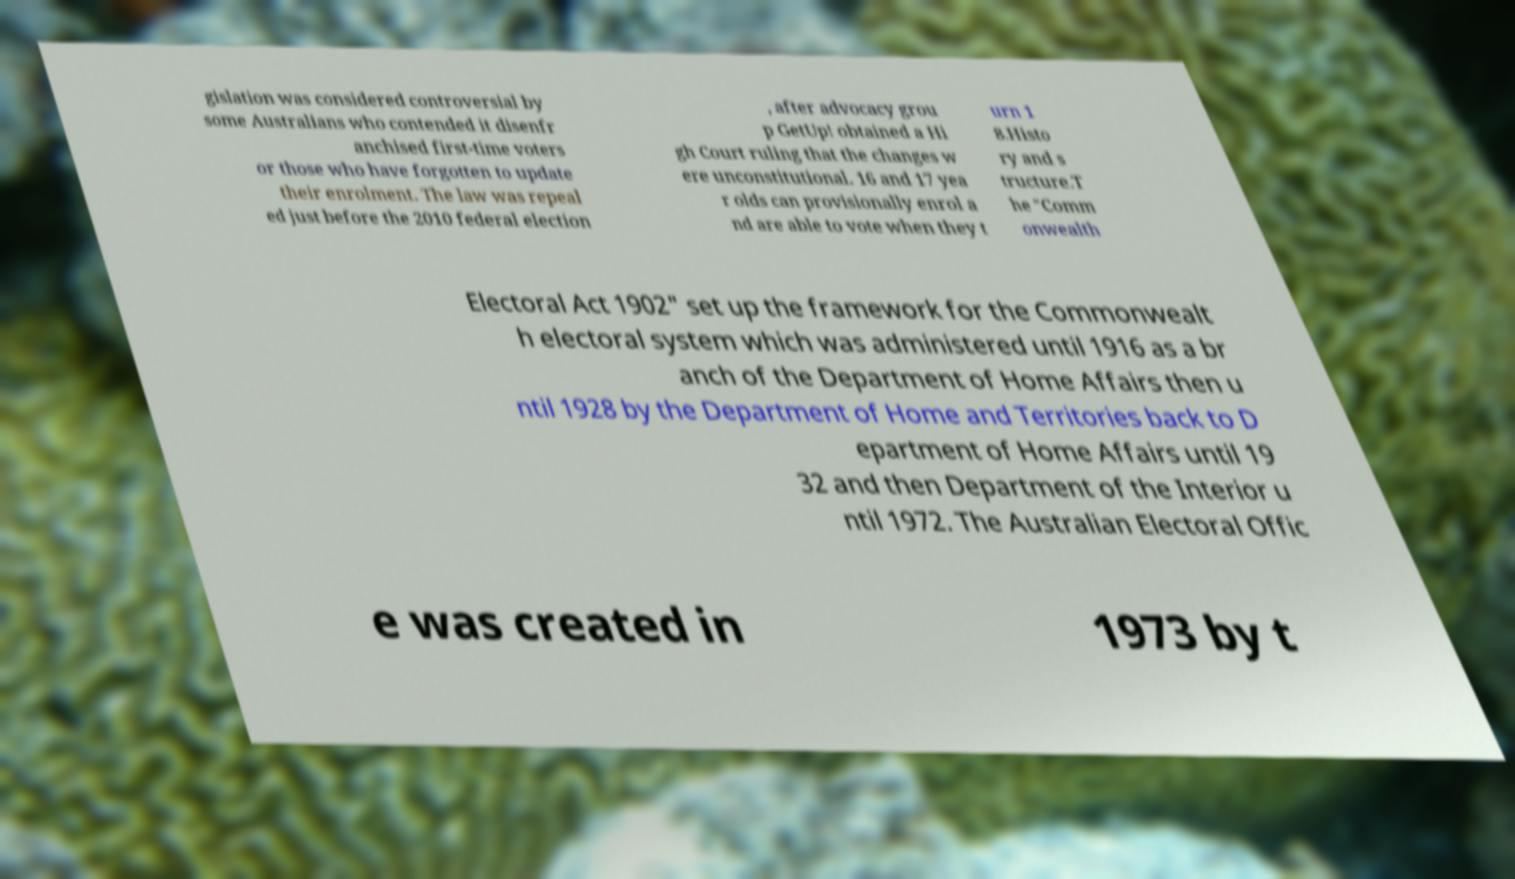There's text embedded in this image that I need extracted. Can you transcribe it verbatim? gislation was considered controversial by some Australians who contended it disenfr anchised first-time voters or those who have forgotten to update their enrolment. The law was repeal ed just before the 2010 federal election , after advocacy grou p GetUp! obtained a Hi gh Court ruling that the changes w ere unconstitutional. 16 and 17 yea r olds can provisionally enrol a nd are able to vote when they t urn 1 8.Histo ry and s tructure.T he "Comm onwealth Electoral Act 1902" set up the framework for the Commonwealt h electoral system which was administered until 1916 as a br anch of the Department of Home Affairs then u ntil 1928 by the Department of Home and Territories back to D epartment of Home Affairs until 19 32 and then Department of the Interior u ntil 1972. The Australian Electoral Offic e was created in 1973 by t 